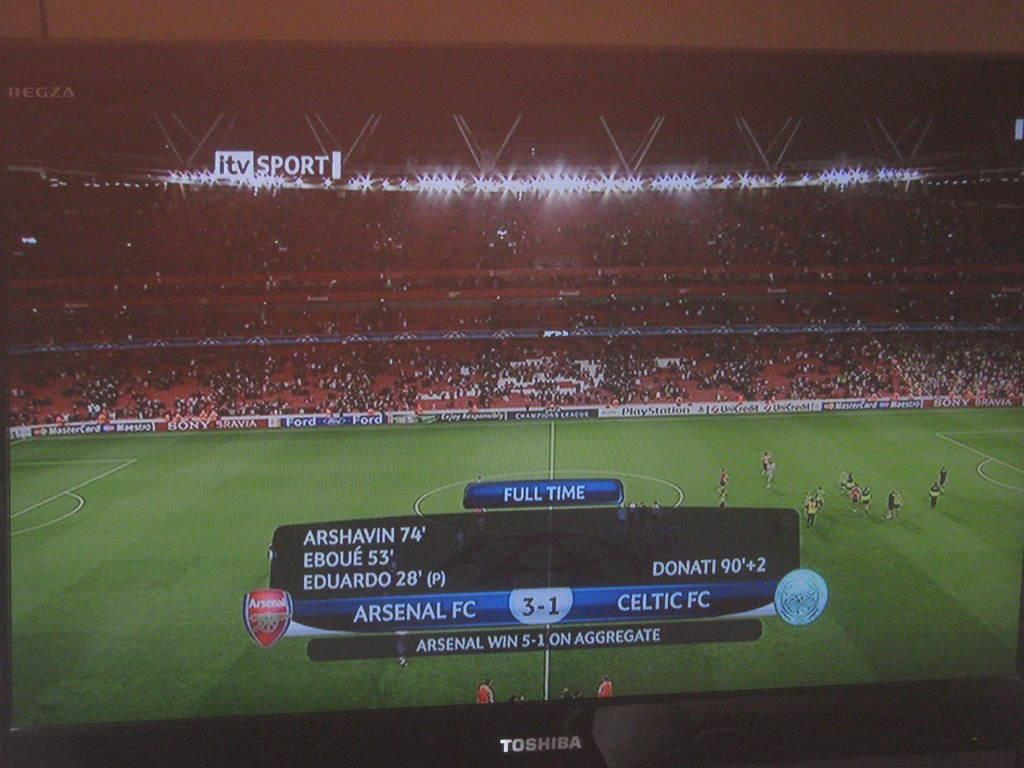<image>
Render a clear and concise summary of the photo. a tv screen on a soccer game, that says its arsenal fc vs celtic fc 